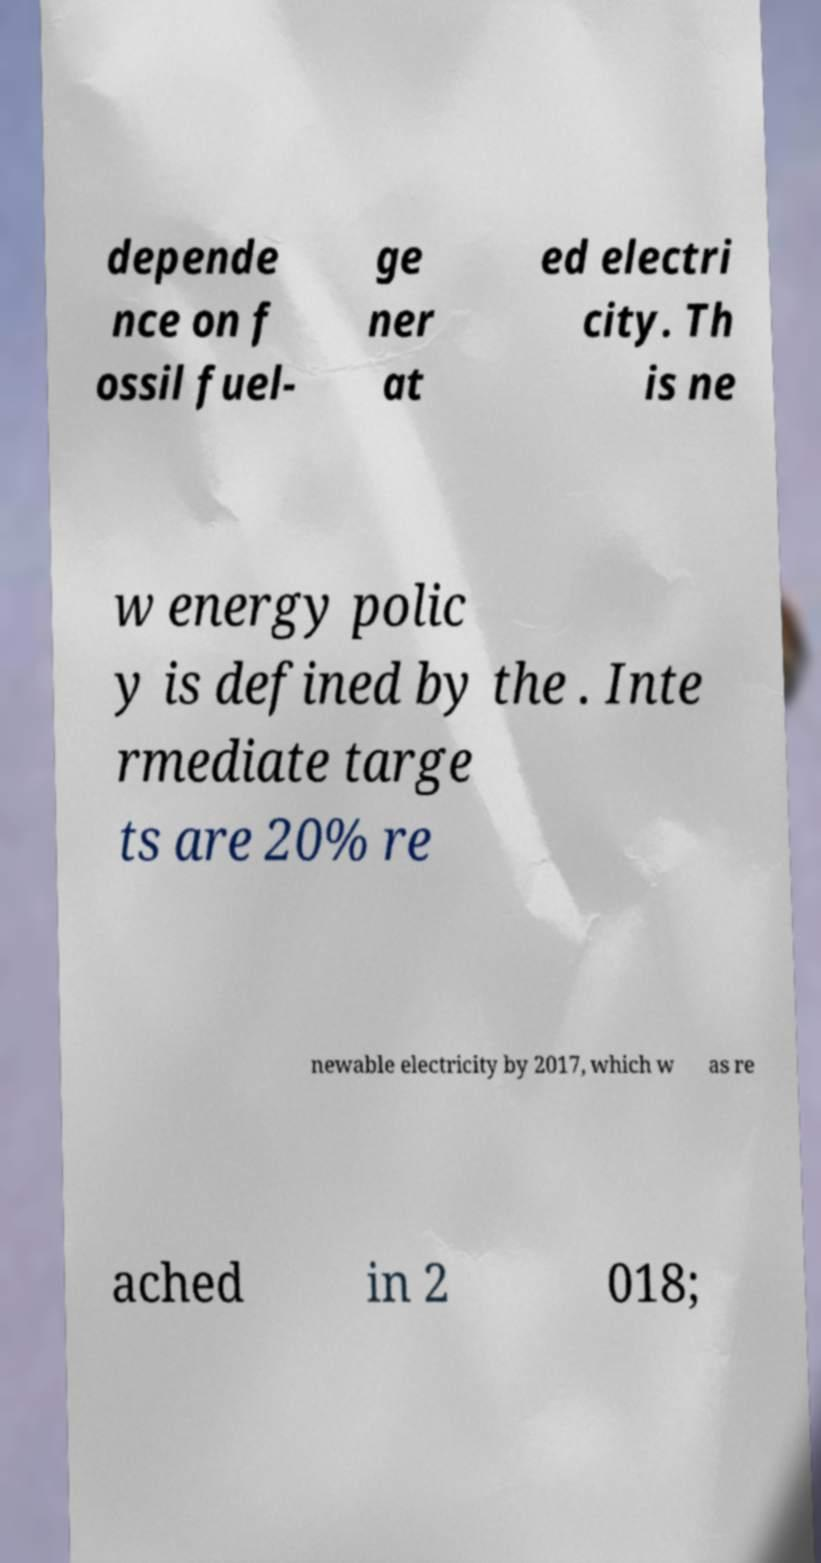I need the written content from this picture converted into text. Can you do that? depende nce on f ossil fuel- ge ner at ed electri city. Th is ne w energy polic y is defined by the . Inte rmediate targe ts are 20% re newable electricity by 2017, which w as re ached in 2 018; 